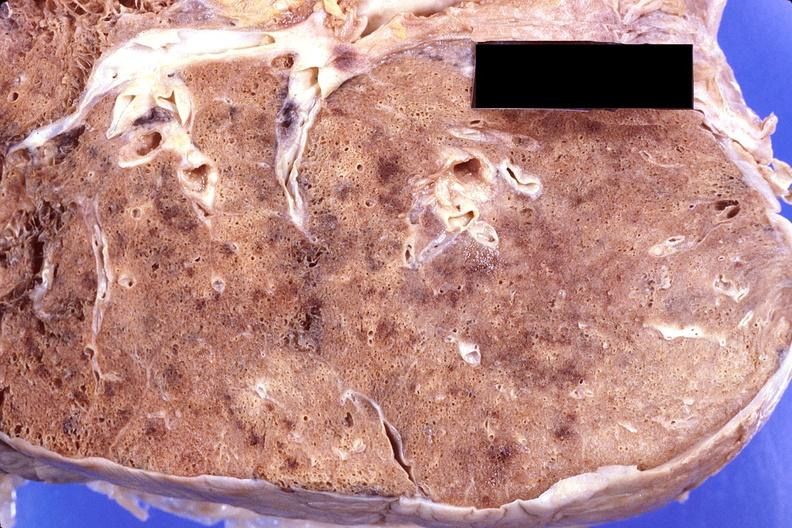s respiratory present?
Answer the question using a single word or phrase. Yes 